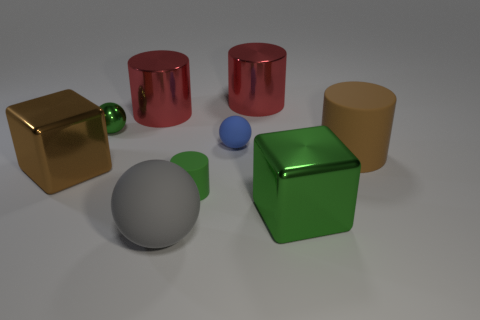Subtract all brown cylinders. How many cylinders are left? 3 Add 1 brown blocks. How many objects exist? 10 Subtract all brown blocks. How many blocks are left? 1 Subtract all cubes. How many objects are left? 7 Subtract 2 cubes. How many cubes are left? 0 Subtract all gray cylinders. How many gray balls are left? 1 Subtract all big yellow matte cylinders. Subtract all big red things. How many objects are left? 7 Add 2 brown cylinders. How many brown cylinders are left? 3 Add 5 tiny brown metal blocks. How many tiny brown metal blocks exist? 5 Subtract 0 purple spheres. How many objects are left? 9 